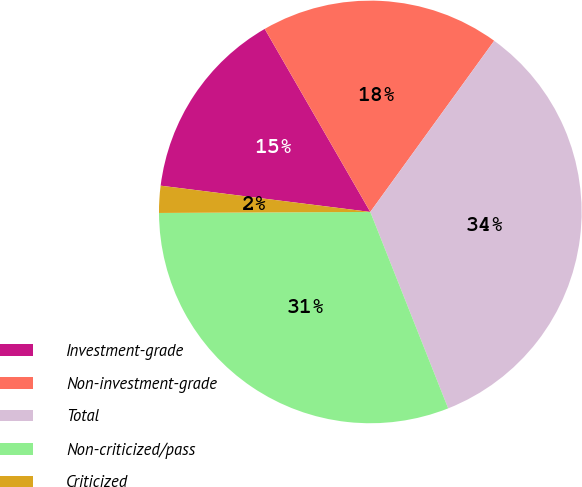Convert chart to OTSL. <chart><loc_0><loc_0><loc_500><loc_500><pie_chart><fcel>Investment-grade<fcel>Non-investment-grade<fcel>Total<fcel>Non-criticized/pass<fcel>Criticized<nl><fcel>14.69%<fcel>18.3%<fcel>34.02%<fcel>30.93%<fcel>2.06%<nl></chart> 